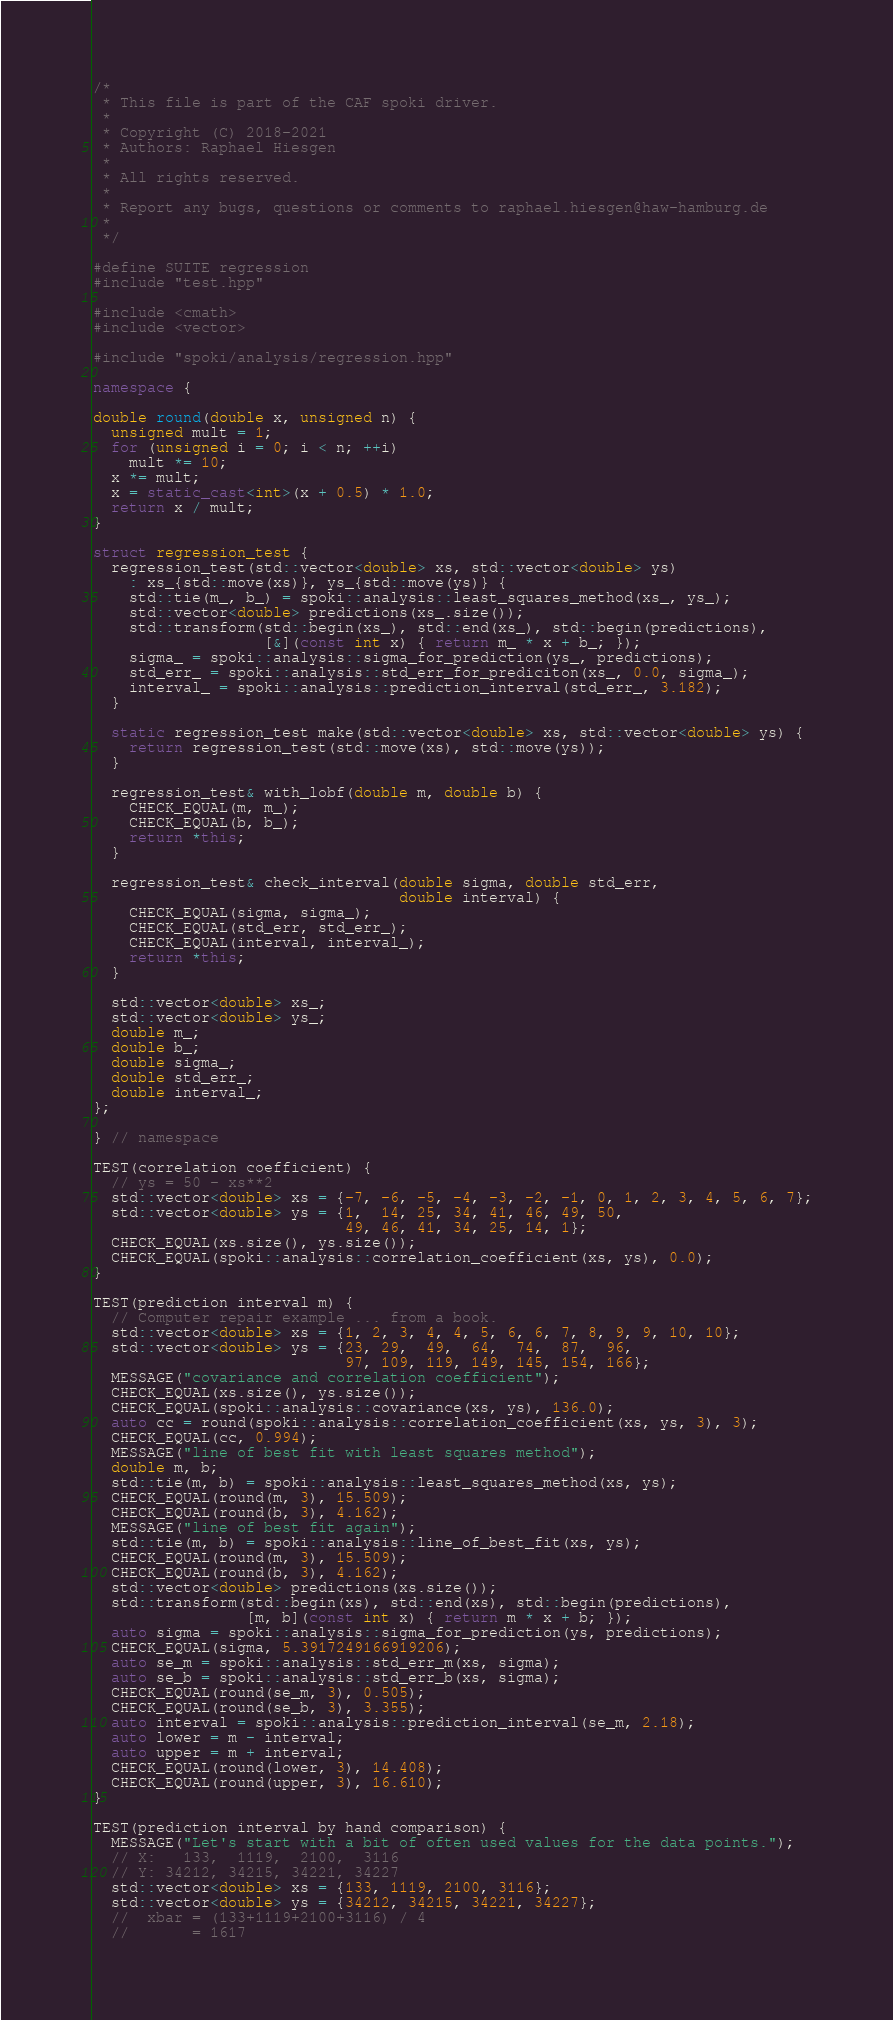<code> <loc_0><loc_0><loc_500><loc_500><_C++_>/*
 * This file is part of the CAF spoki driver.
 *
 * Copyright (C) 2018-2021
 * Authors: Raphael Hiesgen
 *
 * All rights reserved.
 *
 * Report any bugs, questions or comments to raphael.hiesgen@haw-hamburg.de
 *
 */

#define SUITE regression
#include "test.hpp"

#include <cmath>
#include <vector>

#include "spoki/analysis/regression.hpp"

namespace {

double round(double x, unsigned n) {
  unsigned mult = 1;
  for (unsigned i = 0; i < n; ++i)
    mult *= 10;
  x *= mult;
  x = static_cast<int>(x + 0.5) * 1.0;
  return x / mult;
}

struct regression_test {
  regression_test(std::vector<double> xs, std::vector<double> ys)
    : xs_{std::move(xs)}, ys_{std::move(ys)} {
    std::tie(m_, b_) = spoki::analysis::least_squares_method(xs_, ys_);
    std::vector<double> predictions(xs_.size());
    std::transform(std::begin(xs_), std::end(xs_), std::begin(predictions),
                   [&](const int x) { return m_ * x + b_; });
    sigma_ = spoki::analysis::sigma_for_prediction(ys_, predictions);
    std_err_ = spoki::analysis::std_err_for_prediciton(xs_, 0.0, sigma_);
    interval_ = spoki::analysis::prediction_interval(std_err_, 3.182);
  }

  static regression_test make(std::vector<double> xs, std::vector<double> ys) {
    return regression_test(std::move(xs), std::move(ys));
  }

  regression_test& with_lobf(double m, double b) {
    CHECK_EQUAL(m, m_);
    CHECK_EQUAL(b, b_);
    return *this;
  }

  regression_test& check_interval(double sigma, double std_err,
                                  double interval) {
    CHECK_EQUAL(sigma, sigma_);
    CHECK_EQUAL(std_err, std_err_);
    CHECK_EQUAL(interval, interval_);
    return *this;
  }

  std::vector<double> xs_;
  std::vector<double> ys_;
  double m_;
  double b_;
  double sigma_;
  double std_err_;
  double interval_;
};

} // namespace

TEST(correlation coefficient) {
  // ys = 50 - xs**2
  std::vector<double> xs = {-7, -6, -5, -4, -3, -2, -1, 0, 1, 2, 3, 4, 5, 6, 7};
  std::vector<double> ys = {1,  14, 25, 34, 41, 46, 49, 50,
                            49, 46, 41, 34, 25, 14, 1};
  CHECK_EQUAL(xs.size(), ys.size());
  CHECK_EQUAL(spoki::analysis::correlation_coefficient(xs, ys), 0.0);
}

TEST(prediction interval m) {
  // Computer repair example ... from a book.
  std::vector<double> xs = {1, 2, 3, 4, 4, 5, 6, 6, 7, 8, 9, 9, 10, 10};
  std::vector<double> ys = {23, 29,  49,  64,  74,  87,  96,
                            97, 109, 119, 149, 145, 154, 166};
  MESSAGE("covariance and correlation coefficient");
  CHECK_EQUAL(xs.size(), ys.size());
  CHECK_EQUAL(spoki::analysis::covariance(xs, ys), 136.0);
  auto cc = round(spoki::analysis::correlation_coefficient(xs, ys, 3), 3);
  CHECK_EQUAL(cc, 0.994);
  MESSAGE("line of best fit with least squares method");
  double m, b;
  std::tie(m, b) = spoki::analysis::least_squares_method(xs, ys);
  CHECK_EQUAL(round(m, 3), 15.509);
  CHECK_EQUAL(round(b, 3), 4.162);
  MESSAGE("line of best fit again");
  std::tie(m, b) = spoki::analysis::line_of_best_fit(xs, ys);
  CHECK_EQUAL(round(m, 3), 15.509);
  CHECK_EQUAL(round(b, 3), 4.162);
  std::vector<double> predictions(xs.size());
  std::transform(std::begin(xs), std::end(xs), std::begin(predictions),
                 [m, b](const int x) { return m * x + b; });
  auto sigma = spoki::analysis::sigma_for_prediction(ys, predictions);
  CHECK_EQUAL(sigma, 5.3917249166919206);
  auto se_m = spoki::analysis::std_err_m(xs, sigma);
  auto se_b = spoki::analysis::std_err_b(xs, sigma);
  CHECK_EQUAL(round(se_m, 3), 0.505);
  CHECK_EQUAL(round(se_b, 3), 3.355);
  auto interval = spoki::analysis::prediction_interval(se_m, 2.18);
  auto lower = m - interval;
  auto upper = m + interval;
  CHECK_EQUAL(round(lower, 3), 14.408);
  CHECK_EQUAL(round(upper, 3), 16.610);
}

TEST(prediction interval by hand comparison) {
  MESSAGE("Let's start with a bit of often used values for the data points.");
  // X:   133,  1119,  2100,  3116
  // Y: 34212, 34215, 34221, 34227
  std::vector<double> xs = {133, 1119, 2100, 3116};
  std::vector<double> ys = {34212, 34215, 34221, 34227};
  //  xbar = (133+1119+2100+3116) / 4
  //       = 1617</code> 